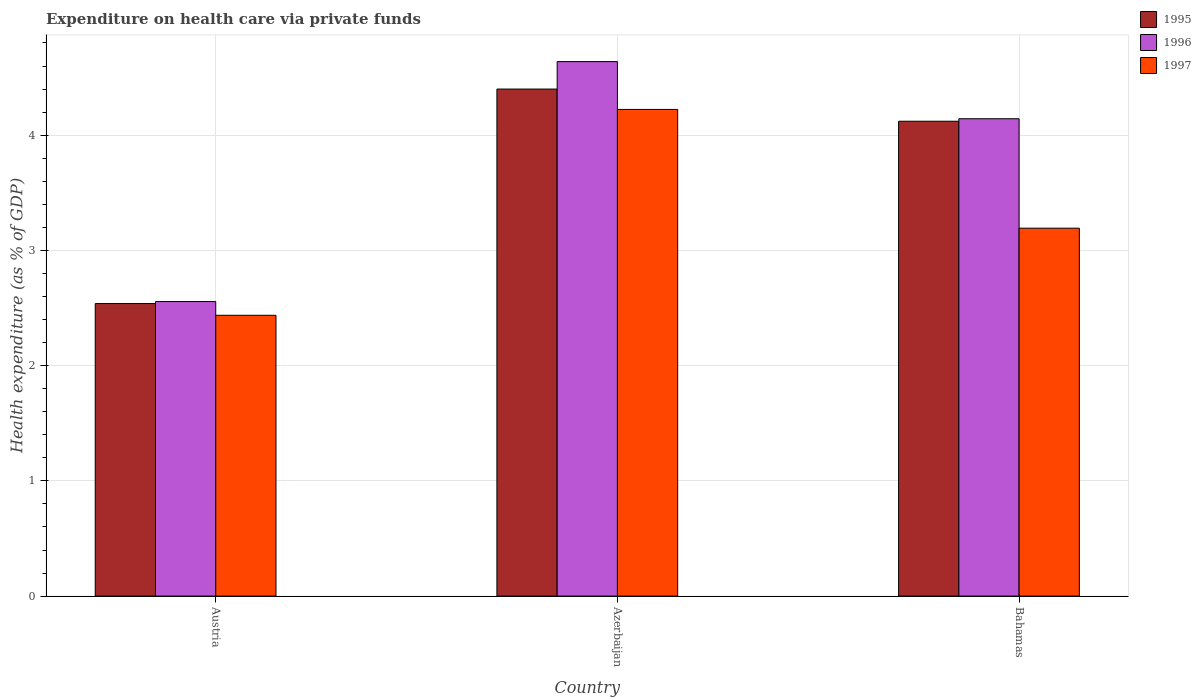Are the number of bars on each tick of the X-axis equal?
Provide a short and direct response. Yes. How many bars are there on the 3rd tick from the left?
Keep it short and to the point. 3. What is the label of the 3rd group of bars from the left?
Your answer should be compact. Bahamas. In how many cases, is the number of bars for a given country not equal to the number of legend labels?
Ensure brevity in your answer.  0. What is the expenditure made on health care in 1997 in Bahamas?
Your answer should be compact. 3.19. Across all countries, what is the maximum expenditure made on health care in 1996?
Your response must be concise. 4.64. Across all countries, what is the minimum expenditure made on health care in 1996?
Ensure brevity in your answer.  2.56. In which country was the expenditure made on health care in 1995 maximum?
Provide a succinct answer. Azerbaijan. In which country was the expenditure made on health care in 1995 minimum?
Your response must be concise. Austria. What is the total expenditure made on health care in 1997 in the graph?
Offer a terse response. 9.85. What is the difference between the expenditure made on health care in 1996 in Azerbaijan and that in Bahamas?
Provide a short and direct response. 0.5. What is the difference between the expenditure made on health care in 1995 in Bahamas and the expenditure made on health care in 1997 in Azerbaijan?
Make the answer very short. -0.1. What is the average expenditure made on health care in 1995 per country?
Provide a short and direct response. 3.69. What is the difference between the expenditure made on health care of/in 1997 and expenditure made on health care of/in 1996 in Azerbaijan?
Offer a very short reply. -0.42. What is the ratio of the expenditure made on health care in 1996 in Austria to that in Azerbaijan?
Make the answer very short. 0.55. Is the difference between the expenditure made on health care in 1997 in Austria and Azerbaijan greater than the difference between the expenditure made on health care in 1996 in Austria and Azerbaijan?
Provide a succinct answer. Yes. What is the difference between the highest and the second highest expenditure made on health care in 1996?
Keep it short and to the point. -2.08. What is the difference between the highest and the lowest expenditure made on health care in 1996?
Ensure brevity in your answer.  2.08. Is the sum of the expenditure made on health care in 1997 in Austria and Azerbaijan greater than the maximum expenditure made on health care in 1995 across all countries?
Ensure brevity in your answer.  Yes. What does the 2nd bar from the right in Azerbaijan represents?
Provide a short and direct response. 1996. Is it the case that in every country, the sum of the expenditure made on health care in 1995 and expenditure made on health care in 1996 is greater than the expenditure made on health care in 1997?
Offer a very short reply. Yes. How many bars are there?
Your answer should be very brief. 9. How many countries are there in the graph?
Make the answer very short. 3. Are the values on the major ticks of Y-axis written in scientific E-notation?
Give a very brief answer. No. Does the graph contain any zero values?
Offer a very short reply. No. Does the graph contain grids?
Your answer should be very brief. Yes. How many legend labels are there?
Offer a terse response. 3. How are the legend labels stacked?
Keep it short and to the point. Vertical. What is the title of the graph?
Provide a short and direct response. Expenditure on health care via private funds. What is the label or title of the Y-axis?
Offer a very short reply. Health expenditure (as % of GDP). What is the Health expenditure (as % of GDP) in 1995 in Austria?
Make the answer very short. 2.54. What is the Health expenditure (as % of GDP) in 1996 in Austria?
Offer a very short reply. 2.56. What is the Health expenditure (as % of GDP) of 1997 in Austria?
Provide a short and direct response. 2.44. What is the Health expenditure (as % of GDP) in 1995 in Azerbaijan?
Give a very brief answer. 4.4. What is the Health expenditure (as % of GDP) in 1996 in Azerbaijan?
Provide a succinct answer. 4.64. What is the Health expenditure (as % of GDP) of 1997 in Azerbaijan?
Offer a very short reply. 4.22. What is the Health expenditure (as % of GDP) in 1995 in Bahamas?
Provide a succinct answer. 4.12. What is the Health expenditure (as % of GDP) in 1996 in Bahamas?
Give a very brief answer. 4.14. What is the Health expenditure (as % of GDP) of 1997 in Bahamas?
Your answer should be compact. 3.19. Across all countries, what is the maximum Health expenditure (as % of GDP) in 1995?
Give a very brief answer. 4.4. Across all countries, what is the maximum Health expenditure (as % of GDP) of 1996?
Provide a succinct answer. 4.64. Across all countries, what is the maximum Health expenditure (as % of GDP) of 1997?
Your answer should be compact. 4.22. Across all countries, what is the minimum Health expenditure (as % of GDP) of 1995?
Provide a succinct answer. 2.54. Across all countries, what is the minimum Health expenditure (as % of GDP) in 1996?
Keep it short and to the point. 2.56. Across all countries, what is the minimum Health expenditure (as % of GDP) of 1997?
Your response must be concise. 2.44. What is the total Health expenditure (as % of GDP) of 1995 in the graph?
Provide a succinct answer. 11.06. What is the total Health expenditure (as % of GDP) in 1996 in the graph?
Your answer should be compact. 11.34. What is the total Health expenditure (as % of GDP) in 1997 in the graph?
Your response must be concise. 9.85. What is the difference between the Health expenditure (as % of GDP) in 1995 in Austria and that in Azerbaijan?
Offer a very short reply. -1.86. What is the difference between the Health expenditure (as % of GDP) of 1996 in Austria and that in Azerbaijan?
Keep it short and to the point. -2.08. What is the difference between the Health expenditure (as % of GDP) of 1997 in Austria and that in Azerbaijan?
Your answer should be compact. -1.79. What is the difference between the Health expenditure (as % of GDP) of 1995 in Austria and that in Bahamas?
Offer a very short reply. -1.58. What is the difference between the Health expenditure (as % of GDP) of 1996 in Austria and that in Bahamas?
Your response must be concise. -1.59. What is the difference between the Health expenditure (as % of GDP) in 1997 in Austria and that in Bahamas?
Offer a very short reply. -0.76. What is the difference between the Health expenditure (as % of GDP) of 1995 in Azerbaijan and that in Bahamas?
Your answer should be compact. 0.28. What is the difference between the Health expenditure (as % of GDP) of 1996 in Azerbaijan and that in Bahamas?
Your response must be concise. 0.5. What is the difference between the Health expenditure (as % of GDP) in 1997 in Azerbaijan and that in Bahamas?
Ensure brevity in your answer.  1.03. What is the difference between the Health expenditure (as % of GDP) in 1995 in Austria and the Health expenditure (as % of GDP) in 1996 in Azerbaijan?
Keep it short and to the point. -2.1. What is the difference between the Health expenditure (as % of GDP) in 1995 in Austria and the Health expenditure (as % of GDP) in 1997 in Azerbaijan?
Offer a very short reply. -1.68. What is the difference between the Health expenditure (as % of GDP) of 1996 in Austria and the Health expenditure (as % of GDP) of 1997 in Azerbaijan?
Offer a terse response. -1.67. What is the difference between the Health expenditure (as % of GDP) in 1995 in Austria and the Health expenditure (as % of GDP) in 1996 in Bahamas?
Your answer should be compact. -1.6. What is the difference between the Health expenditure (as % of GDP) in 1995 in Austria and the Health expenditure (as % of GDP) in 1997 in Bahamas?
Give a very brief answer. -0.65. What is the difference between the Health expenditure (as % of GDP) of 1996 in Austria and the Health expenditure (as % of GDP) of 1997 in Bahamas?
Ensure brevity in your answer.  -0.64. What is the difference between the Health expenditure (as % of GDP) in 1995 in Azerbaijan and the Health expenditure (as % of GDP) in 1996 in Bahamas?
Your answer should be very brief. 0.26. What is the difference between the Health expenditure (as % of GDP) in 1995 in Azerbaijan and the Health expenditure (as % of GDP) in 1997 in Bahamas?
Ensure brevity in your answer.  1.21. What is the difference between the Health expenditure (as % of GDP) in 1996 in Azerbaijan and the Health expenditure (as % of GDP) in 1997 in Bahamas?
Your answer should be very brief. 1.45. What is the average Health expenditure (as % of GDP) of 1995 per country?
Your answer should be compact. 3.69. What is the average Health expenditure (as % of GDP) of 1996 per country?
Make the answer very short. 3.78. What is the average Health expenditure (as % of GDP) of 1997 per country?
Keep it short and to the point. 3.28. What is the difference between the Health expenditure (as % of GDP) of 1995 and Health expenditure (as % of GDP) of 1996 in Austria?
Your answer should be very brief. -0.02. What is the difference between the Health expenditure (as % of GDP) in 1995 and Health expenditure (as % of GDP) in 1997 in Austria?
Make the answer very short. 0.1. What is the difference between the Health expenditure (as % of GDP) of 1996 and Health expenditure (as % of GDP) of 1997 in Austria?
Give a very brief answer. 0.12. What is the difference between the Health expenditure (as % of GDP) of 1995 and Health expenditure (as % of GDP) of 1996 in Azerbaijan?
Your answer should be compact. -0.24. What is the difference between the Health expenditure (as % of GDP) in 1995 and Health expenditure (as % of GDP) in 1997 in Azerbaijan?
Your answer should be very brief. 0.18. What is the difference between the Health expenditure (as % of GDP) of 1996 and Health expenditure (as % of GDP) of 1997 in Azerbaijan?
Offer a terse response. 0.41. What is the difference between the Health expenditure (as % of GDP) of 1995 and Health expenditure (as % of GDP) of 1996 in Bahamas?
Give a very brief answer. -0.02. What is the difference between the Health expenditure (as % of GDP) in 1995 and Health expenditure (as % of GDP) in 1997 in Bahamas?
Your answer should be compact. 0.93. What is the difference between the Health expenditure (as % of GDP) in 1996 and Health expenditure (as % of GDP) in 1997 in Bahamas?
Offer a terse response. 0.95. What is the ratio of the Health expenditure (as % of GDP) in 1995 in Austria to that in Azerbaijan?
Keep it short and to the point. 0.58. What is the ratio of the Health expenditure (as % of GDP) in 1996 in Austria to that in Azerbaijan?
Your answer should be compact. 0.55. What is the ratio of the Health expenditure (as % of GDP) in 1997 in Austria to that in Azerbaijan?
Make the answer very short. 0.58. What is the ratio of the Health expenditure (as % of GDP) in 1995 in Austria to that in Bahamas?
Make the answer very short. 0.62. What is the ratio of the Health expenditure (as % of GDP) of 1996 in Austria to that in Bahamas?
Your response must be concise. 0.62. What is the ratio of the Health expenditure (as % of GDP) in 1997 in Austria to that in Bahamas?
Your answer should be compact. 0.76. What is the ratio of the Health expenditure (as % of GDP) in 1995 in Azerbaijan to that in Bahamas?
Provide a short and direct response. 1.07. What is the ratio of the Health expenditure (as % of GDP) of 1996 in Azerbaijan to that in Bahamas?
Provide a short and direct response. 1.12. What is the ratio of the Health expenditure (as % of GDP) of 1997 in Azerbaijan to that in Bahamas?
Ensure brevity in your answer.  1.32. What is the difference between the highest and the second highest Health expenditure (as % of GDP) in 1995?
Your response must be concise. 0.28. What is the difference between the highest and the second highest Health expenditure (as % of GDP) in 1996?
Make the answer very short. 0.5. What is the difference between the highest and the second highest Health expenditure (as % of GDP) of 1997?
Make the answer very short. 1.03. What is the difference between the highest and the lowest Health expenditure (as % of GDP) in 1995?
Offer a very short reply. 1.86. What is the difference between the highest and the lowest Health expenditure (as % of GDP) of 1996?
Ensure brevity in your answer.  2.08. What is the difference between the highest and the lowest Health expenditure (as % of GDP) of 1997?
Keep it short and to the point. 1.79. 